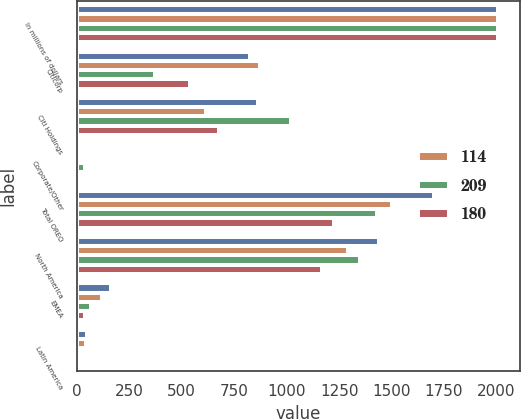Convert chart to OTSL. <chart><loc_0><loc_0><loc_500><loc_500><stacked_bar_chart><ecel><fcel>In millions of dollars<fcel>Citicorp<fcel>Citi Holdings<fcel>Corporate/Other<fcel>Total OREO<fcel>North America<fcel>EMEA<fcel>Latin America<nl><fcel>nan<fcel>2010<fcel>826<fcel>863<fcel>14<fcel>1703<fcel>1440<fcel>161<fcel>47<nl><fcel>114<fcel>2009<fcel>874<fcel>615<fcel>11<fcel>1500<fcel>1294<fcel>121<fcel>45<nl><fcel>209<fcel>2008<fcel>371<fcel>1022<fcel>40<fcel>1433<fcel>1349<fcel>66<fcel>16<nl><fcel>180<fcel>2007<fcel>541<fcel>679<fcel>8<fcel>1228<fcel>1168<fcel>40<fcel>17<nl></chart> 